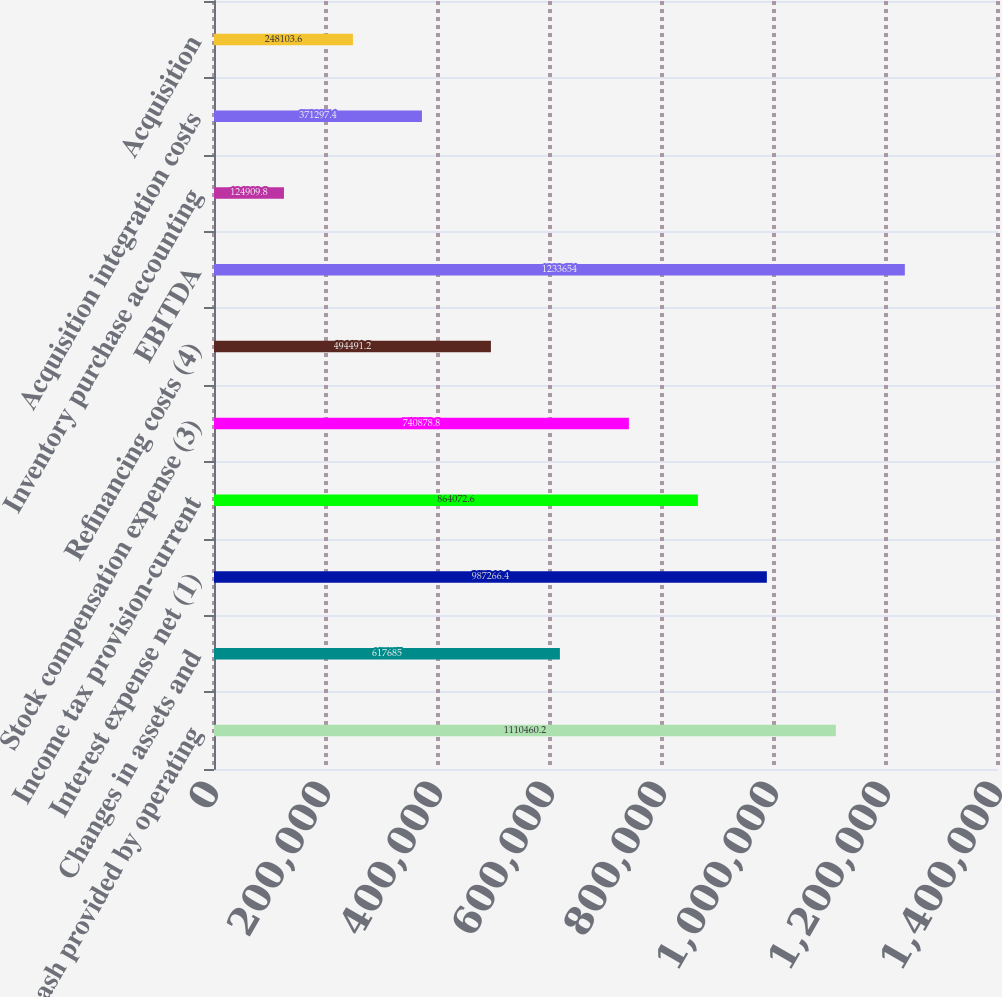<chart> <loc_0><loc_0><loc_500><loc_500><bar_chart><fcel>Net cash provided by operating<fcel>Changes in assets and<fcel>Interest expense net (1)<fcel>Income tax provision-current<fcel>Stock compensation expense (3)<fcel>Refinancing costs (4)<fcel>EBITDA<fcel>Inventory purchase accounting<fcel>Acquisition integration costs<fcel>Acquisition<nl><fcel>1.11046e+06<fcel>617685<fcel>987266<fcel>864073<fcel>740879<fcel>494491<fcel>1.23365e+06<fcel>124910<fcel>371297<fcel>248104<nl></chart> 